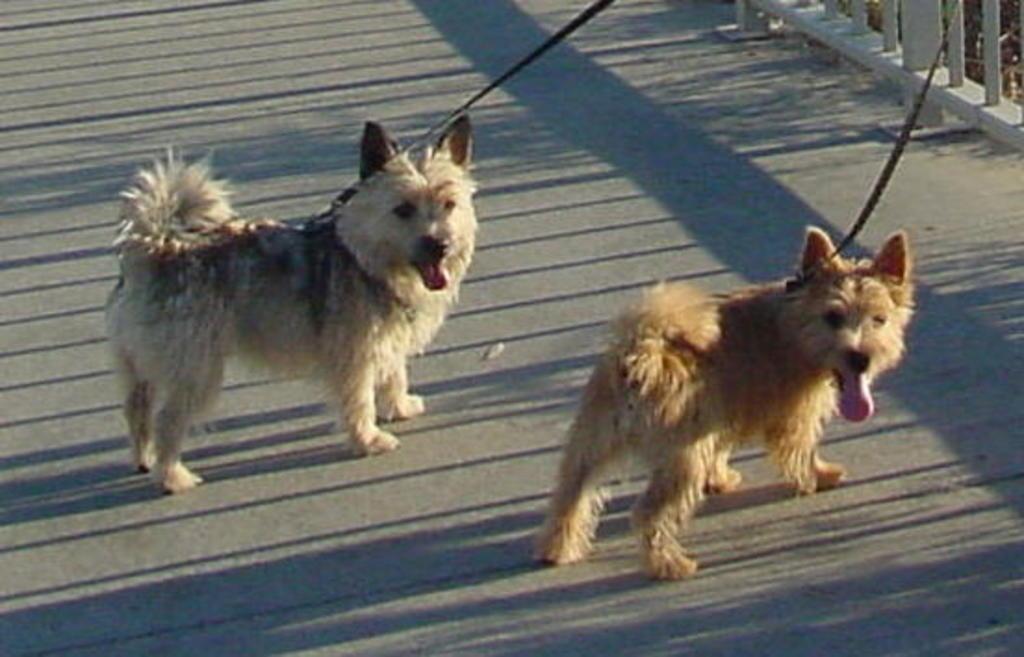How many dogs are in the image? There are two dogs in the image. What are the colors of the dogs? One dog is white, and the other is brown. What can be seen around the necks of the dogs? Both dogs have belts around their necks. What is visible in the background of the image? There is a fence in the background of the image. How many bikes are being ridden by the dogs in the image? There are no bikes present in the image, and the dogs are not riding any bikes. 